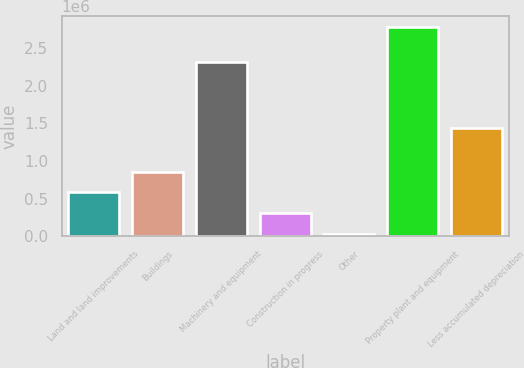<chart> <loc_0><loc_0><loc_500><loc_500><bar_chart><fcel>Land and land improvements<fcel>Buildings<fcel>Machinery and equipment<fcel>Construction in progress<fcel>Other<fcel>Property plant and equipment<fcel>Less accumulated depreciation<nl><fcel>584657<fcel>859351<fcel>2.31083e+06<fcel>309962<fcel>35267<fcel>2.78222e+06<fcel>1.43706e+06<nl></chart> 